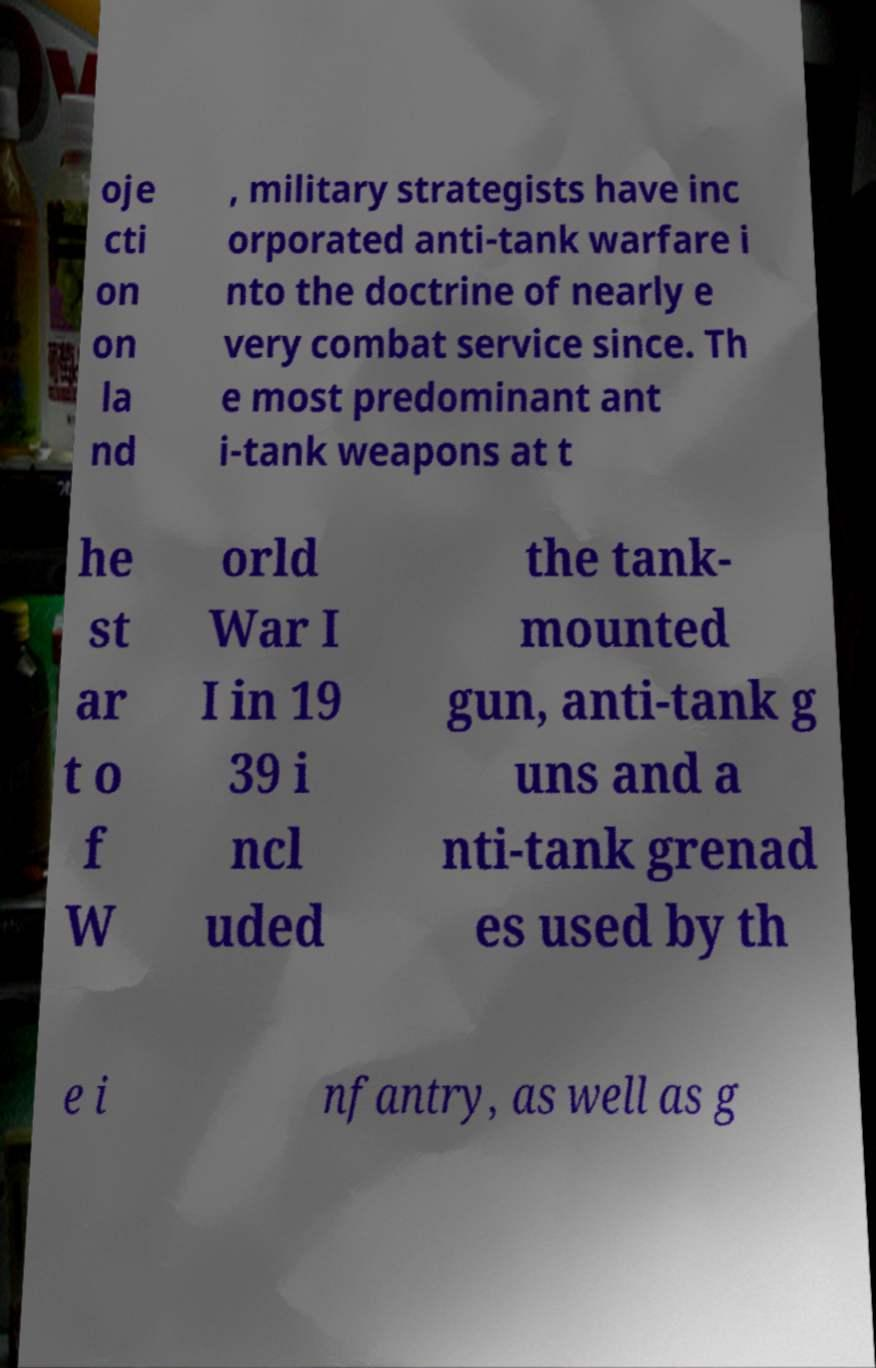What messages or text are displayed in this image? I need them in a readable, typed format. oje cti on on la nd , military strategists have inc orporated anti-tank warfare i nto the doctrine of nearly e very combat service since. Th e most predominant ant i-tank weapons at t he st ar t o f W orld War I I in 19 39 i ncl uded the tank- mounted gun, anti-tank g uns and a nti-tank grenad es used by th e i nfantry, as well as g 